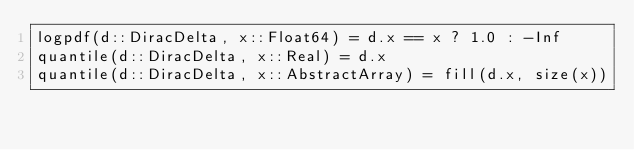<code> <loc_0><loc_0><loc_500><loc_500><_Julia_>logpdf(d::DiracDelta, x::Float64) = d.x == x ? 1.0 : -Inf
quantile(d::DiracDelta, x::Real) = d.x
quantile(d::DiracDelta, x::AbstractArray) = fill(d.x, size(x))
</code> 